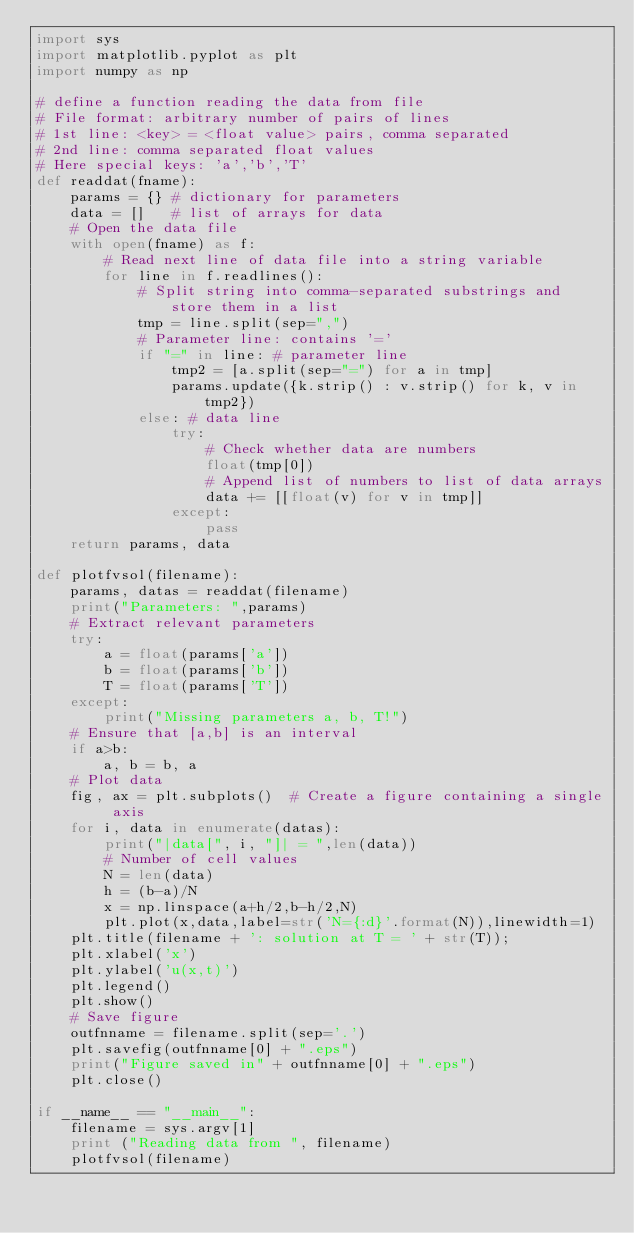Convert code to text. <code><loc_0><loc_0><loc_500><loc_500><_Python_>import sys
import matplotlib.pyplot as plt
import numpy as np

# define a function reading the data from file
# File format: arbitrary number of pairs of lines
# 1st line: <key> = <float value> pairs, comma separated
# 2nd line: comma separated float values
# Here special keys: 'a','b','T'
def readdat(fname):
    params = {} # dictionary for parameters 
    data = []   # list of arrays for data
    # Open the data file
    with open(fname) as f:
        # Read next line of data file into a string variable
        for line in f.readlines():
            # Split string into comma-separated substrings and store them in a list
            tmp = line.split(sep=",")
            # Parameter line: contains '='
            if "=" in line: # parameter line
                tmp2 = [a.split(sep="=") for a in tmp]
                params.update({k.strip() : v.strip() for k, v in tmp2})
            else: # data line
                try:
                    # Check whether data are numbers 
                    float(tmp[0])
                    # Append list of numbers to list of data arrays 
                    data += [[float(v) for v in tmp]]
                except:
                    pass
    return params, data

def plotfvsol(filename):
    params, datas = readdat(filename)
    print("Parameters: ",params)
    # Extract relevant parameters 
    try:
        a = float(params['a'])
        b = float(params['b'])
        T = float(params['T'])
    except:
        print("Missing parameters a, b, T!")
    # Ensure that [a,b] is an interval 
    if a>b:
        a, b = b, a
    # Plot data
    fig, ax = plt.subplots()  # Create a figure containing a single axis
    for i, data in enumerate(datas):
        print("|data[", i, "]| = ",len(data))
        # Number of cell values 
        N = len(data)
        h = (b-a)/N
        x = np.linspace(a+h/2,b-h/2,N)
        plt.plot(x,data,label=str('N={:d}'.format(N)),linewidth=1)
    plt.title(filename + ': solution at T = ' + str(T));    
    plt.xlabel('x')
    plt.ylabel('u(x,t)')
    plt.legend()
    plt.show()
    # Save figure
    outfnname = filename.split(sep='.')
    plt.savefig(outfnname[0] + ".eps")
    print("Figure saved in" + outfnname[0] + ".eps")
    plt.close()

if __name__ == "__main__":
    filename = sys.argv[1]
    print ("Reading data from ", filename)
    plotfvsol(filename)
        
</code> 